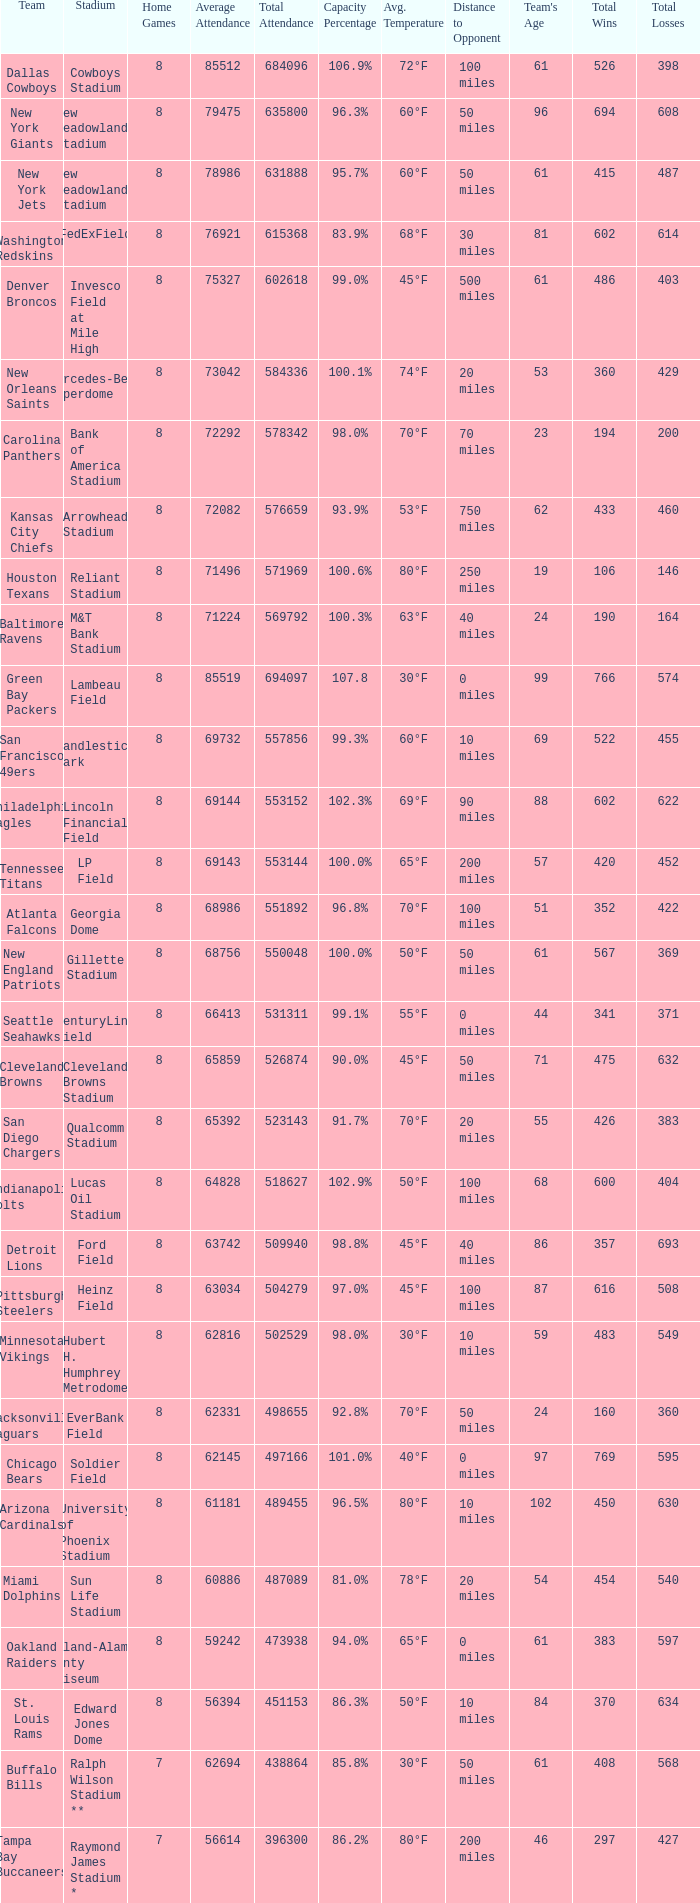I'm looking to parse the entire table for insights. Could you assist me with that? {'header': ['Team', 'Stadium', 'Home Games', 'Average Attendance', 'Total Attendance', 'Capacity Percentage', 'Avg. Temperature', 'Distance to Opponent', "Team's Age", 'Total Wins', 'Total Losses'], 'rows': [['Dallas Cowboys', 'Cowboys Stadium', '8', '85512', '684096', '106.9%', '72°F', '100 miles', '61', '526', '398'], ['New York Giants', 'New Meadowlands Stadium', '8', '79475', '635800', '96.3%', '60°F', '50 miles', '96', '694', '608'], ['New York Jets', 'New Meadowlands Stadium', '8', '78986', '631888', '95.7%', '60°F', '50 miles', '61', '415', '487'], ['Washington Redskins', 'FedExField', '8', '76921', '615368', '83.9%', '68°F', '30 miles', '81', '602', '614'], ['Denver Broncos', 'Invesco Field at Mile High', '8', '75327', '602618', '99.0%', '45°F', '500 miles', '61', '486', '403'], ['New Orleans Saints', 'Mercedes-Benz Superdome', '8', '73042', '584336', '100.1%', '74°F', '20 miles', '53', '360', '429'], ['Carolina Panthers', 'Bank of America Stadium', '8', '72292', '578342', '98.0%', '70°F', '70 miles', '23', '194', '200'], ['Kansas City Chiefs', 'Arrowhead Stadium', '8', '72082', '576659', '93.9%', '53°F', '750 miles', '62', '433', '460'], ['Houston Texans', 'Reliant Stadium', '8', '71496', '571969', '100.6%', '80°F', '250 miles', '19', '106', '146'], ['Baltimore Ravens', 'M&T Bank Stadium', '8', '71224', '569792', '100.3%', '63°F', '40 miles', '24', '190', '164'], ['Green Bay Packers', 'Lambeau Field', '8', '85519', '694097', '107.8', '30°F', '0 miles', '99', '766', '574'], ['San Francisco 49ers', 'Candlestick Park', '8', '69732', '557856', '99.3%', '60°F', '10 miles', '69', '522', '455'], ['Philadelphia Eagles', 'Lincoln Financial Field', '8', '69144', '553152', '102.3%', '69°F', '90 miles', '88', '602', '622'], ['Tennessee Titans', 'LP Field', '8', '69143', '553144', '100.0%', '65°F', '200 miles', '57', '420', '452'], ['Atlanta Falcons', 'Georgia Dome', '8', '68986', '551892', '96.8%', '70°F', '100 miles', '51', '352', '422'], ['New England Patriots', 'Gillette Stadium', '8', '68756', '550048', '100.0%', '50°F', '50 miles', '61', '567', '369'], ['Seattle Seahawks', 'CenturyLink Field', '8', '66413', '531311', '99.1%', '55°F', '0 miles', '44', '341', '371'], ['Cleveland Browns', 'Cleveland Browns Stadium', '8', '65859', '526874', '90.0%', '45°F', '50 miles', '71', '475', '632'], ['San Diego Chargers', 'Qualcomm Stadium', '8', '65392', '523143', '91.7%', '70°F', '20 miles', '55', '426', '383'], ['Indianapolis Colts', 'Lucas Oil Stadium', '8', '64828', '518627', '102.9%', '50°F', '100 miles', '68', '600', '404'], ['Detroit Lions', 'Ford Field', '8', '63742', '509940', '98.8%', '45°F', '40 miles', '86', '357', '693'], ['Pittsburgh Steelers', 'Heinz Field', '8', '63034', '504279', '97.0%', '45°F', '100 miles', '87', '616', '508'], ['Minnesota Vikings', 'Hubert H. Humphrey Metrodome', '8', '62816', '502529', '98.0%', '30°F', '10 miles', '59', '483', '549'], ['Jacksonville Jaguars', 'EverBank Field', '8', '62331', '498655', '92.8%', '70°F', '50 miles', '24', '160', '360'], ['Chicago Bears', 'Soldier Field', '8', '62145', '497166', '101.0%', '40°F', '0 miles', '97', '769', '595'], ['Arizona Cardinals', 'University of Phoenix Stadium', '8', '61181', '489455', '96.5%', '80°F', '10 miles', '102', '450', '630'], ['Miami Dolphins', 'Sun Life Stadium', '8', '60886', '487089', '81.0%', '78°F', '20 miles', '54', '454', '540'], ['Oakland Raiders', 'Oakland-Alameda County Coliseum', '8', '59242', '473938', '94.0%', '65°F', '0 miles', '61', '383', '597'], ['St. Louis Rams', 'Edward Jones Dome', '8', '56394', '451153', '86.3%', '50°F', '10 miles', '84', '370', '634'], ['Buffalo Bills', 'Ralph Wilson Stadium **', '7', '62694', '438864', '85.8%', '30°F', '50 miles', '61', '408', '568'], ['Tampa Bay Buccaneers', 'Raymond James Stadium *', '7', '56614', '396300', '86.2%', '80°F', '200 miles', '46', '297', '427']]} What is the capacity percentage when the total attendance is 509940? 98.8%. 